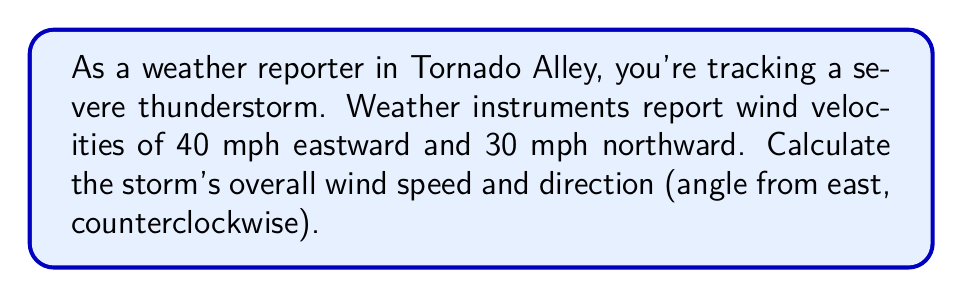Give your solution to this math problem. To solve this problem, we'll use vector components and trigonometry:

1. Identify the components:
   East component: $v_x = 40$ mph
   North component: $v_y = 30$ mph

2. Calculate the wind speed using the Pythagorean theorem:
   $$\text{Speed} = \sqrt{v_x^2 + v_y^2} = \sqrt{40^2 + 30^2} = \sqrt{1600 + 900} = \sqrt{2500} = 50 \text{ mph}$$

3. Calculate the direction using the arctangent function:
   $$\theta = \arctan\left(\frac{v_y}{v_x}\right) = \arctan\left(\frac{30}{40}\right) = \arctan(0.75) \approx 36.87°$$

The angle is measured counterclockwise from east, so no further adjustment is needed.

[asy]
import geometry;

draw((-1,0)--(4,0),arrow=Arrow(TeXHead));
draw((0,-1)--(0,3),arrow=Arrow(TeXHead));
draw((0,0)--(4,3),arrow=Arrow(TeXHead));

label("East", (4,0), E);
label("North", (0,3), N);
label("40 mph", (2,0), S);
label("30 mph", (4,1.5), E);
label("50 mph", (2,1.5), NW);
label("36.87°", (0.7,0.2), NE);

dot((0,0));
[/asy]
Answer: The storm's overall wind speed is 50 mph, and its direction is 36.87° north of east. 